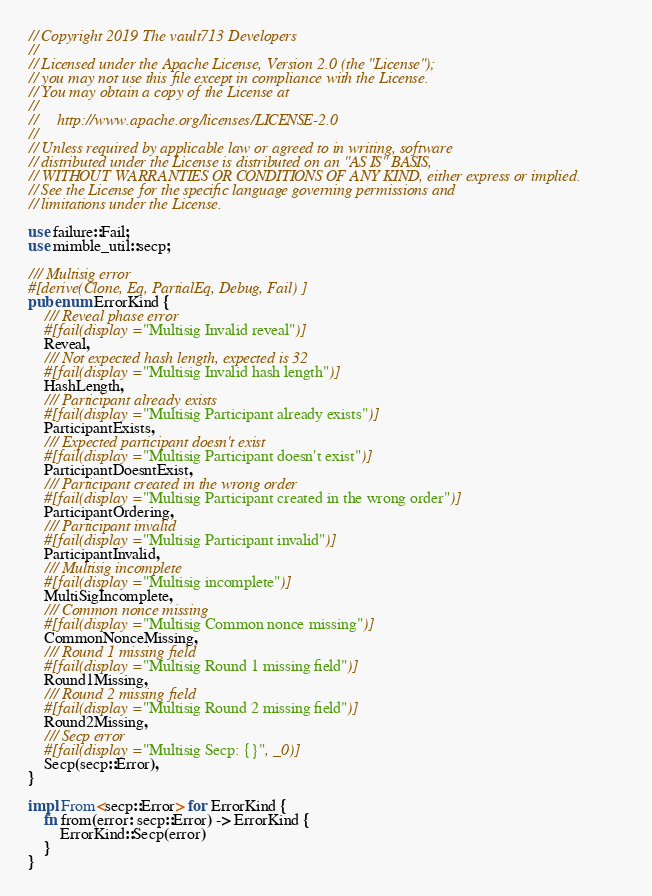Convert code to text. <code><loc_0><loc_0><loc_500><loc_500><_Rust_>// Copyright 2019 The vault713 Developers
//
// Licensed under the Apache License, Version 2.0 (the "License");
// you may not use this file except in compliance with the License.
// You may obtain a copy of the License at
//
//     http://www.apache.org/licenses/LICENSE-2.0
//
// Unless required by applicable law or agreed to in writing, software
// distributed under the License is distributed on an "AS IS" BASIS,
// WITHOUT WARRANTIES OR CONDITIONS OF ANY KIND, either express or implied.
// See the License for the specific language governing permissions and
// limitations under the License.

use failure::Fail;
use mimble_util::secp;

/// Multisig error
#[derive(Clone, Eq, PartialEq, Debug, Fail)]
pub enum ErrorKind {
	/// Reveal phase error
	#[fail(display = "Multisig Invalid reveal")]
	Reveal,
	/// Not expected hash length, expected is 32
	#[fail(display = "Multisig Invalid hash length")]
	HashLength,
	/// Participant already exists
	#[fail(display = "Multisig Participant already exists")]
	ParticipantExists,
	/// Expected participant doesn't exist
	#[fail(display = "Multisig Participant doesn't exist")]
	ParticipantDoesntExist,
	/// Participant created in the wrong order
	#[fail(display = "Multisig Participant created in the wrong order")]
	ParticipantOrdering,
	/// Participant invalid
	#[fail(display = "Multisig Participant invalid")]
	ParticipantInvalid,
	/// Multisig incomplete
	#[fail(display = "Multisig incomplete")]
	MultiSigIncomplete,
	/// Common nonce missing
	#[fail(display = "Multisig Common nonce missing")]
	CommonNonceMissing,
	/// Round 1 missing field
	#[fail(display = "Multisig Round 1 missing field")]
	Round1Missing,
	/// Round 2 missing field
	#[fail(display = "Multisig Round 2 missing field")]
	Round2Missing,
	/// Secp error
	#[fail(display = "Multisig Secp: {}", _0)]
	Secp(secp::Error),
}

impl From<secp::Error> for ErrorKind {
	fn from(error: secp::Error) -> ErrorKind {
		ErrorKind::Secp(error)
	}
}
</code> 